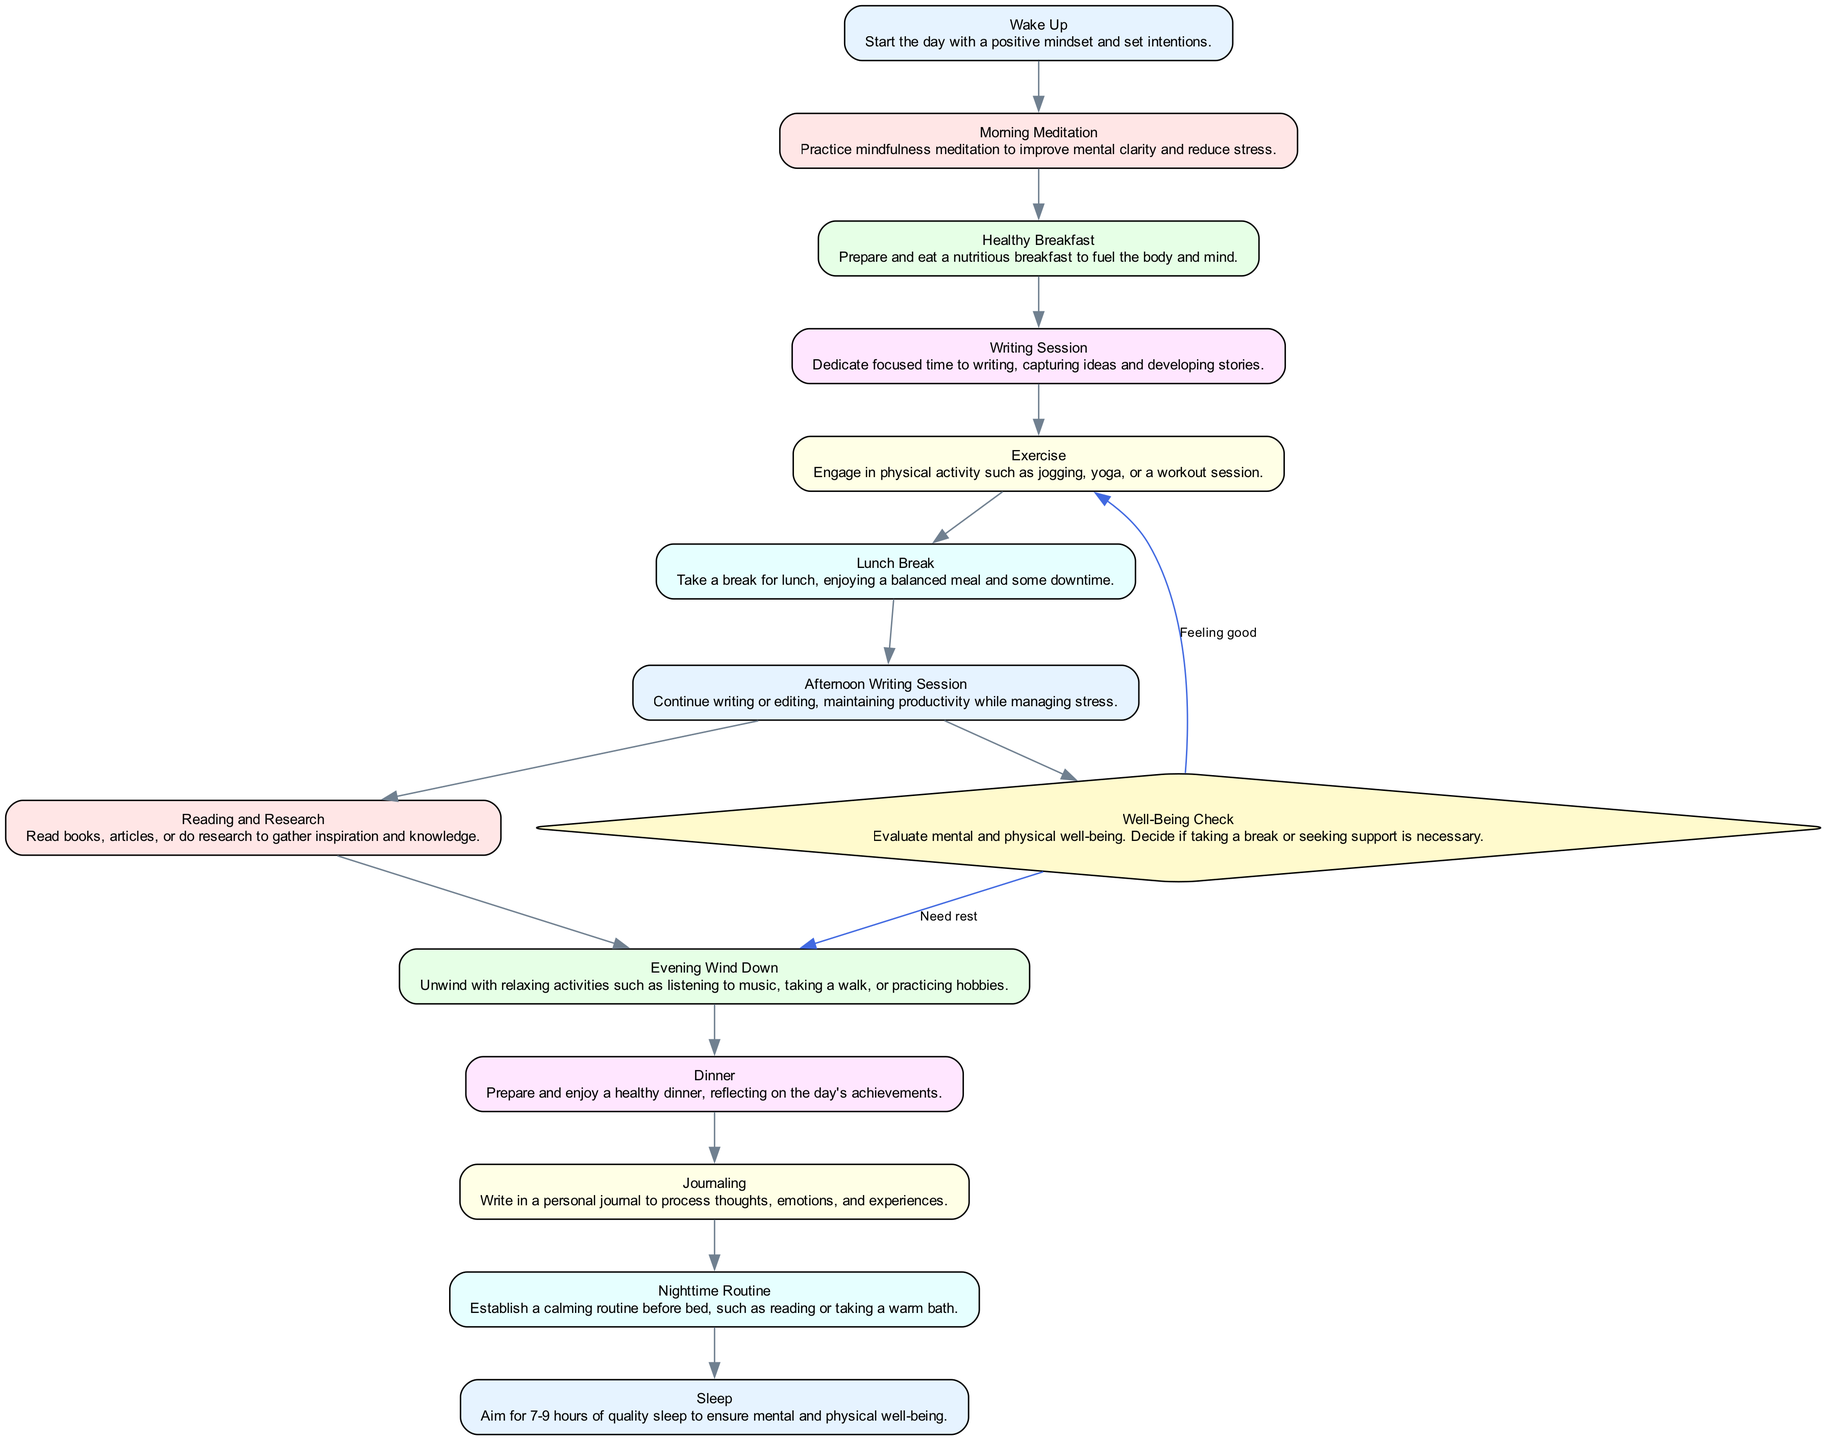What is the first activity in the diagram? The diagram starts with the "Wake Up" activity. This is the initial node in the flow, indicating the beginning of the writer's daily routine.
Answer: Wake Up How many activities are listed in the diagram? There are 12 activities in total, as counted by the nodes that represent the various steps in the writer's daily routine.
Answer: 12 What activity follows "Healthy Breakfast"? The "Writing Session" directly follows "Healthy Breakfast" in the flow of the diagram, indicating that after having breakfast, the writer dedicates time to writing.
Answer: Writing Session What decision is present in the diagram? The "Well-Being Check" is the only decision node represented in the diagram, which serves to evaluate the writer's mental and physical health during the routine.
Answer: Well-Being Check If a break is needed after the "Well-Being Check," what is the next activity? If rest is needed after the "Well-Being Check," the next flow leads to "Evening Wind Down." This means if the writer decides they need a break, they will move to unwind instead of exercising.
Answer: Evening Wind Down Which activity occurs after "Afternoon Writing Session"? After the "Afternoon Writing Session," the writer proceeds to "Reading and Research." This indicates a continuation of productive activities aimed at enriching their writing.
Answer: Reading and Research How does the flow return after "Well-Being Check" if feeling good? If feeling good, the flow returns to "Exercise" after the "Well-Being Check," allowing the writer to continue their routine actively.
Answer: Exercise What is the last activity before "Sleep"? The last activity before "Sleep" is "Nighttime Routine," where the writer establishes a calming routine as they prepare for sleep, promoting better rest.
Answer: Nighttime Routine 